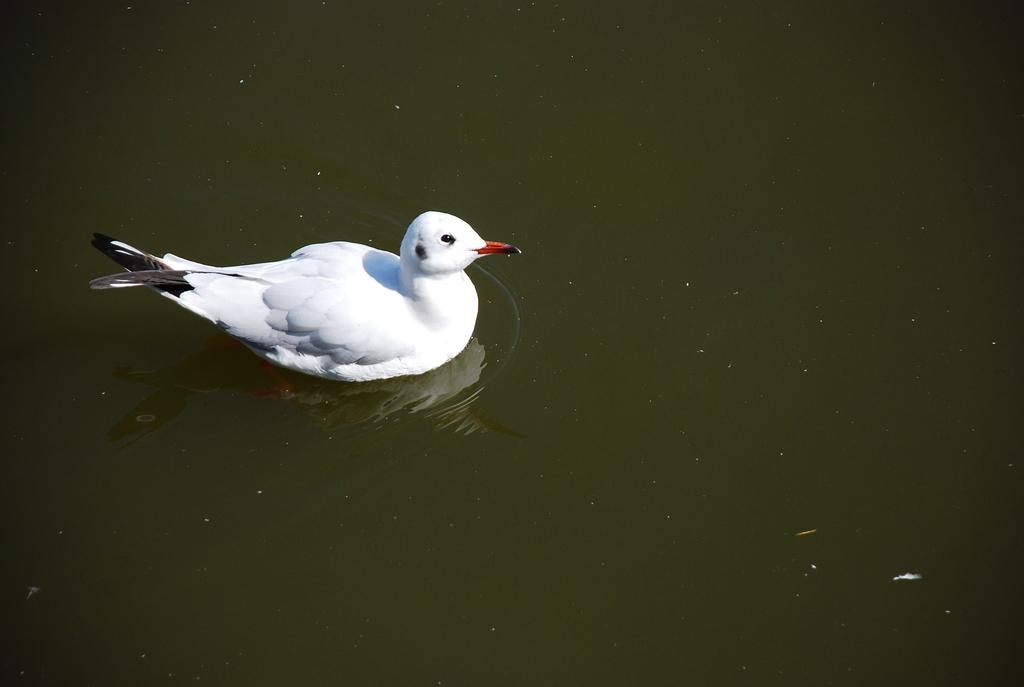What type of animal is in the image? There is a white-colored duck in the image. Where is the duck located? The duck is in the water. What word does the duck say to its friend at the event in the image? There is no reference to a friend or an event in the image, and ducks do not speak human language. 